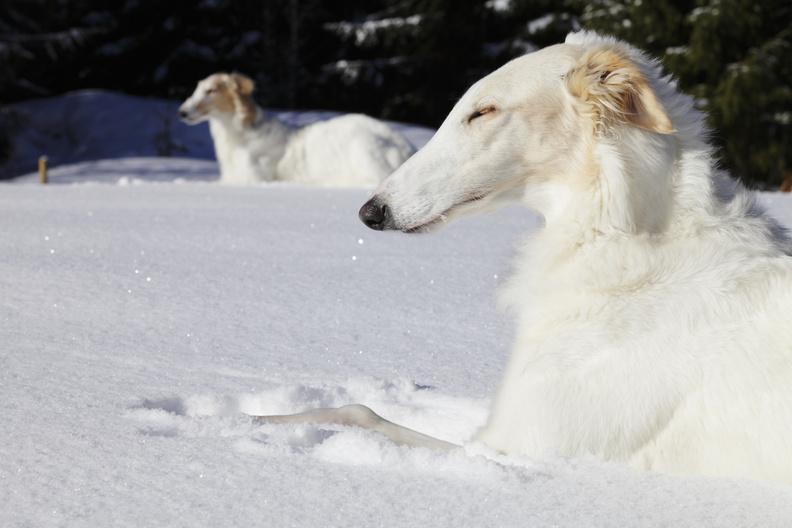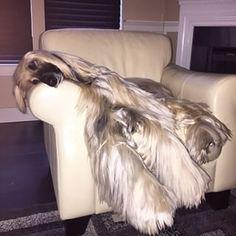The first image is the image on the left, the second image is the image on the right. For the images displayed, is the sentence "there is a female sitting with a dog in one of the images" factually correct? Answer yes or no. No. The first image is the image on the left, the second image is the image on the right. Given the left and right images, does the statement "There are at least two white dogs in the right image." hold true? Answer yes or no. No. 